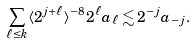Convert formula to latex. <formula><loc_0><loc_0><loc_500><loc_500>\sum _ { \ell \leq k } \langle 2 ^ { j + \ell } \rangle ^ { - 8 } 2 ^ { \ell } a _ { \ell } \lesssim 2 ^ { - j } a _ { - j } .</formula> 